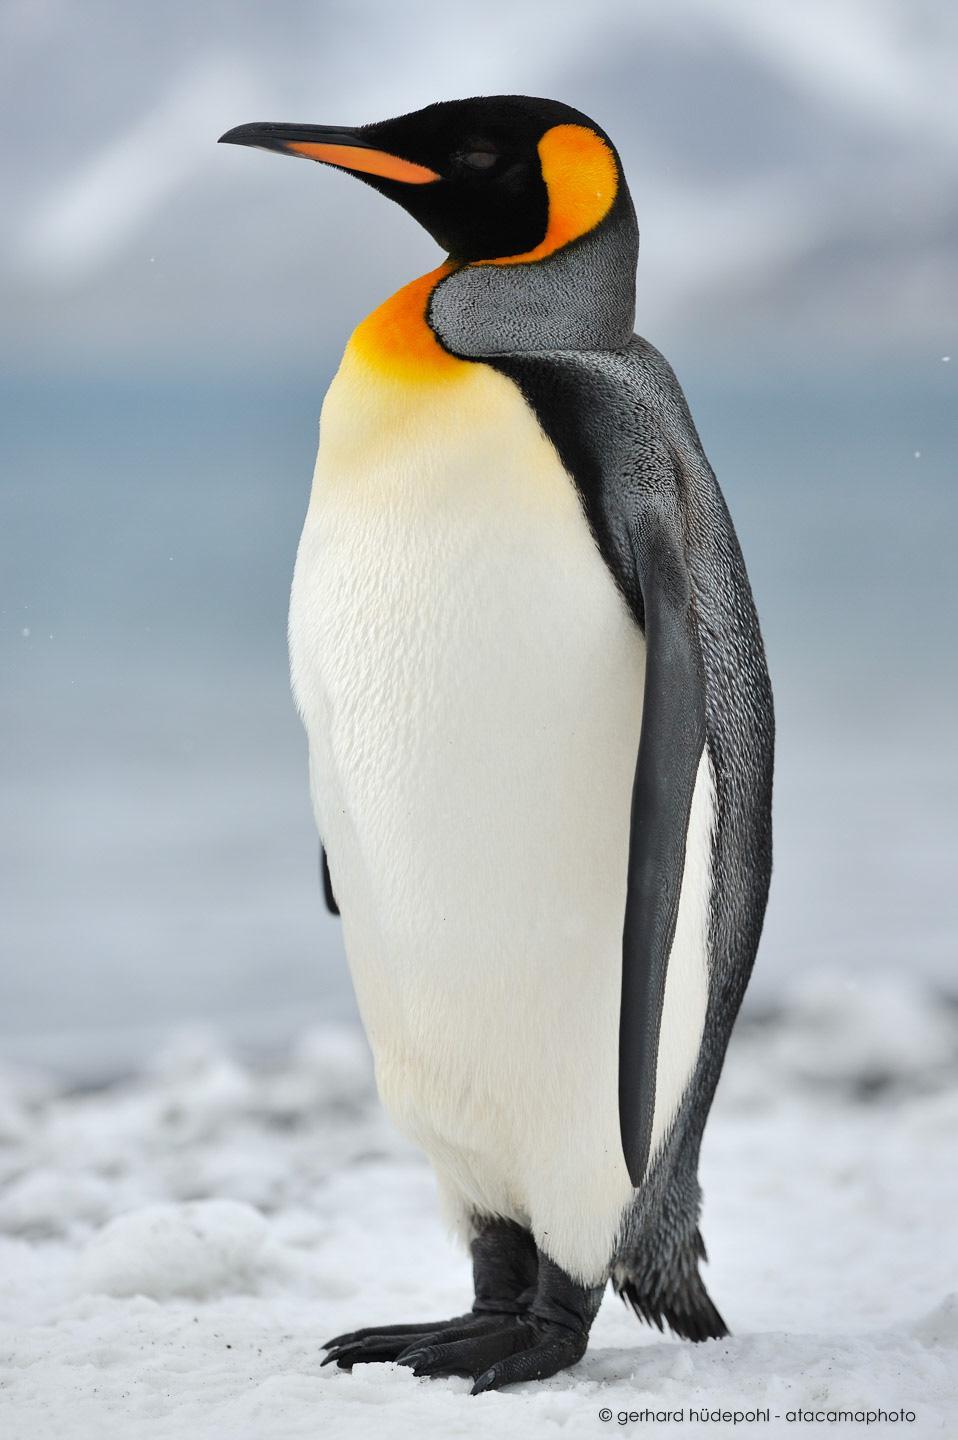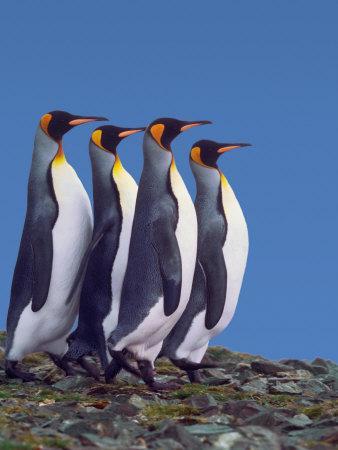The first image is the image on the left, the second image is the image on the right. Given the left and right images, does the statement "At least one of the images show only one penguin." hold true? Answer yes or no. Yes. The first image is the image on the left, the second image is the image on the right. For the images displayed, is the sentence "There is exactly one animal in the image on the left." factually correct? Answer yes or no. Yes. 